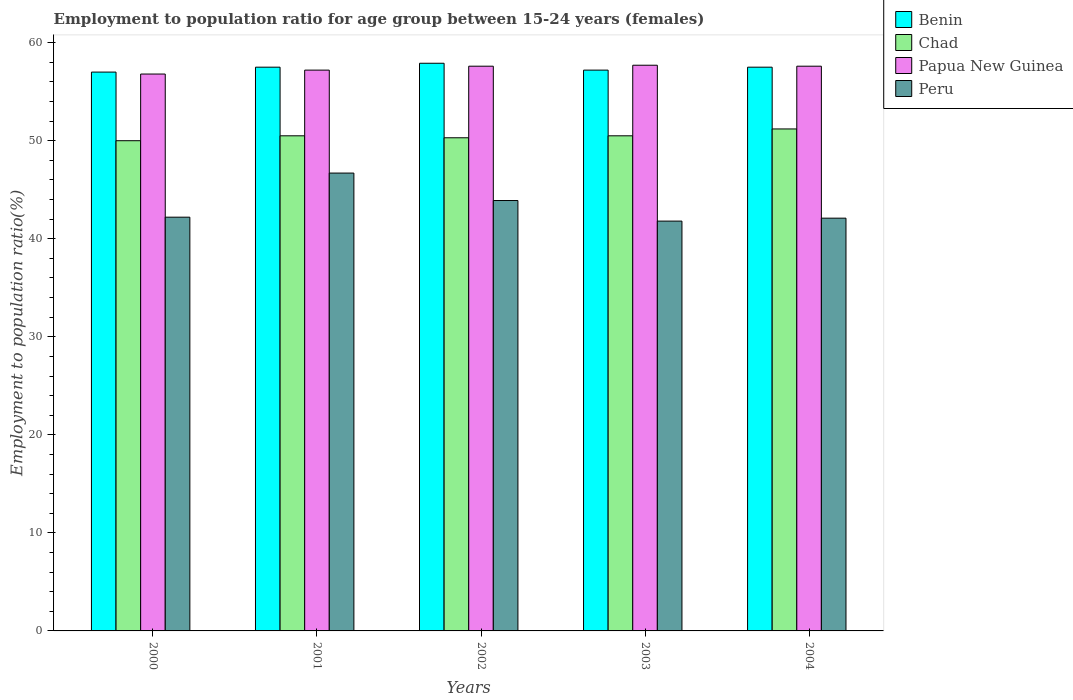How many different coloured bars are there?
Offer a terse response. 4. Are the number of bars per tick equal to the number of legend labels?
Make the answer very short. Yes. Are the number of bars on each tick of the X-axis equal?
Offer a terse response. Yes. How many bars are there on the 2nd tick from the left?
Offer a terse response. 4. What is the employment to population ratio in Peru in 2001?
Your answer should be compact. 46.7. Across all years, what is the maximum employment to population ratio in Papua New Guinea?
Keep it short and to the point. 57.7. Across all years, what is the minimum employment to population ratio in Peru?
Your response must be concise. 41.8. What is the total employment to population ratio in Peru in the graph?
Ensure brevity in your answer.  216.7. What is the difference between the employment to population ratio in Peru in 2000 and that in 2001?
Your answer should be compact. -4.5. What is the difference between the employment to population ratio in Benin in 2003 and the employment to population ratio in Papua New Guinea in 2002?
Ensure brevity in your answer.  -0.4. What is the average employment to population ratio in Peru per year?
Provide a short and direct response. 43.34. In the year 2002, what is the difference between the employment to population ratio in Papua New Guinea and employment to population ratio in Peru?
Offer a terse response. 13.7. In how many years, is the employment to population ratio in Peru greater than 12 %?
Make the answer very short. 5. What is the ratio of the employment to population ratio in Benin in 2002 to that in 2004?
Keep it short and to the point. 1.01. What is the difference between the highest and the second highest employment to population ratio in Peru?
Give a very brief answer. 2.8. What is the difference between the highest and the lowest employment to population ratio in Benin?
Your answer should be very brief. 0.9. In how many years, is the employment to population ratio in Chad greater than the average employment to population ratio in Chad taken over all years?
Your response must be concise. 1. Is the sum of the employment to population ratio in Benin in 2002 and 2003 greater than the maximum employment to population ratio in Peru across all years?
Your answer should be compact. Yes. Is it the case that in every year, the sum of the employment to population ratio in Benin and employment to population ratio in Chad is greater than the sum of employment to population ratio in Papua New Guinea and employment to population ratio in Peru?
Offer a terse response. Yes. What does the 3rd bar from the left in 2004 represents?
Give a very brief answer. Papua New Guinea. What does the 2nd bar from the right in 2002 represents?
Provide a short and direct response. Papua New Guinea. Is it the case that in every year, the sum of the employment to population ratio in Benin and employment to population ratio in Chad is greater than the employment to population ratio in Peru?
Your answer should be very brief. Yes. Are all the bars in the graph horizontal?
Your answer should be very brief. No. Where does the legend appear in the graph?
Your answer should be very brief. Top right. How many legend labels are there?
Offer a very short reply. 4. What is the title of the graph?
Your answer should be very brief. Employment to population ratio for age group between 15-24 years (females). What is the Employment to population ratio(%) of Benin in 2000?
Offer a very short reply. 57. What is the Employment to population ratio(%) of Chad in 2000?
Your answer should be very brief. 50. What is the Employment to population ratio(%) in Papua New Guinea in 2000?
Your answer should be compact. 56.8. What is the Employment to population ratio(%) in Peru in 2000?
Your response must be concise. 42.2. What is the Employment to population ratio(%) of Benin in 2001?
Provide a succinct answer. 57.5. What is the Employment to population ratio(%) in Chad in 2001?
Ensure brevity in your answer.  50.5. What is the Employment to population ratio(%) in Papua New Guinea in 2001?
Offer a very short reply. 57.2. What is the Employment to population ratio(%) of Peru in 2001?
Give a very brief answer. 46.7. What is the Employment to population ratio(%) in Benin in 2002?
Your answer should be very brief. 57.9. What is the Employment to population ratio(%) of Chad in 2002?
Give a very brief answer. 50.3. What is the Employment to population ratio(%) in Papua New Guinea in 2002?
Offer a terse response. 57.6. What is the Employment to population ratio(%) in Peru in 2002?
Provide a short and direct response. 43.9. What is the Employment to population ratio(%) of Benin in 2003?
Offer a terse response. 57.2. What is the Employment to population ratio(%) in Chad in 2003?
Provide a short and direct response. 50.5. What is the Employment to population ratio(%) in Papua New Guinea in 2003?
Your response must be concise. 57.7. What is the Employment to population ratio(%) of Peru in 2003?
Offer a very short reply. 41.8. What is the Employment to population ratio(%) of Benin in 2004?
Your answer should be compact. 57.5. What is the Employment to population ratio(%) in Chad in 2004?
Ensure brevity in your answer.  51.2. What is the Employment to population ratio(%) of Papua New Guinea in 2004?
Offer a terse response. 57.6. What is the Employment to population ratio(%) of Peru in 2004?
Offer a very short reply. 42.1. Across all years, what is the maximum Employment to population ratio(%) of Benin?
Make the answer very short. 57.9. Across all years, what is the maximum Employment to population ratio(%) in Chad?
Give a very brief answer. 51.2. Across all years, what is the maximum Employment to population ratio(%) of Papua New Guinea?
Offer a terse response. 57.7. Across all years, what is the maximum Employment to population ratio(%) of Peru?
Provide a short and direct response. 46.7. Across all years, what is the minimum Employment to population ratio(%) in Papua New Guinea?
Your answer should be very brief. 56.8. Across all years, what is the minimum Employment to population ratio(%) in Peru?
Your answer should be very brief. 41.8. What is the total Employment to population ratio(%) of Benin in the graph?
Make the answer very short. 287.1. What is the total Employment to population ratio(%) in Chad in the graph?
Offer a very short reply. 252.5. What is the total Employment to population ratio(%) of Papua New Guinea in the graph?
Offer a terse response. 286.9. What is the total Employment to population ratio(%) of Peru in the graph?
Make the answer very short. 216.7. What is the difference between the Employment to population ratio(%) in Benin in 2000 and that in 2001?
Offer a very short reply. -0.5. What is the difference between the Employment to population ratio(%) in Benin in 2000 and that in 2002?
Make the answer very short. -0.9. What is the difference between the Employment to population ratio(%) of Chad in 2000 and that in 2002?
Give a very brief answer. -0.3. What is the difference between the Employment to population ratio(%) of Peru in 2000 and that in 2002?
Your answer should be very brief. -1.7. What is the difference between the Employment to population ratio(%) of Benin in 2000 and that in 2004?
Provide a short and direct response. -0.5. What is the difference between the Employment to population ratio(%) of Papua New Guinea in 2000 and that in 2004?
Ensure brevity in your answer.  -0.8. What is the difference between the Employment to population ratio(%) of Peru in 2000 and that in 2004?
Ensure brevity in your answer.  0.1. What is the difference between the Employment to population ratio(%) of Benin in 2001 and that in 2002?
Give a very brief answer. -0.4. What is the difference between the Employment to population ratio(%) in Papua New Guinea in 2001 and that in 2002?
Ensure brevity in your answer.  -0.4. What is the difference between the Employment to population ratio(%) of Peru in 2001 and that in 2002?
Your response must be concise. 2.8. What is the difference between the Employment to population ratio(%) in Benin in 2002 and that in 2003?
Make the answer very short. 0.7. What is the difference between the Employment to population ratio(%) of Chad in 2002 and that in 2003?
Ensure brevity in your answer.  -0.2. What is the difference between the Employment to population ratio(%) of Benin in 2003 and that in 2004?
Your answer should be very brief. -0.3. What is the difference between the Employment to population ratio(%) of Papua New Guinea in 2003 and that in 2004?
Offer a very short reply. 0.1. What is the difference between the Employment to population ratio(%) in Benin in 2000 and the Employment to population ratio(%) in Chad in 2001?
Make the answer very short. 6.5. What is the difference between the Employment to population ratio(%) of Chad in 2000 and the Employment to population ratio(%) of Papua New Guinea in 2001?
Keep it short and to the point. -7.2. What is the difference between the Employment to population ratio(%) in Papua New Guinea in 2000 and the Employment to population ratio(%) in Peru in 2001?
Offer a terse response. 10.1. What is the difference between the Employment to population ratio(%) of Benin in 2000 and the Employment to population ratio(%) of Chad in 2002?
Your answer should be very brief. 6.7. What is the difference between the Employment to population ratio(%) in Benin in 2000 and the Employment to population ratio(%) in Peru in 2003?
Give a very brief answer. 15.2. What is the difference between the Employment to population ratio(%) in Chad in 2000 and the Employment to population ratio(%) in Papua New Guinea in 2003?
Make the answer very short. -7.7. What is the difference between the Employment to population ratio(%) in Chad in 2000 and the Employment to population ratio(%) in Peru in 2003?
Your answer should be compact. 8.2. What is the difference between the Employment to population ratio(%) of Papua New Guinea in 2000 and the Employment to population ratio(%) of Peru in 2003?
Your answer should be very brief. 15. What is the difference between the Employment to population ratio(%) of Benin in 2000 and the Employment to population ratio(%) of Chad in 2004?
Offer a terse response. 5.8. What is the difference between the Employment to population ratio(%) of Chad in 2000 and the Employment to population ratio(%) of Papua New Guinea in 2004?
Your answer should be compact. -7.6. What is the difference between the Employment to population ratio(%) of Papua New Guinea in 2000 and the Employment to population ratio(%) of Peru in 2004?
Ensure brevity in your answer.  14.7. What is the difference between the Employment to population ratio(%) of Benin in 2001 and the Employment to population ratio(%) of Papua New Guinea in 2002?
Give a very brief answer. -0.1. What is the difference between the Employment to population ratio(%) in Benin in 2001 and the Employment to population ratio(%) in Peru in 2002?
Make the answer very short. 13.6. What is the difference between the Employment to population ratio(%) of Benin in 2001 and the Employment to population ratio(%) of Chad in 2003?
Offer a very short reply. 7. What is the difference between the Employment to population ratio(%) of Chad in 2001 and the Employment to population ratio(%) of Peru in 2003?
Your answer should be very brief. 8.7. What is the difference between the Employment to population ratio(%) of Papua New Guinea in 2001 and the Employment to population ratio(%) of Peru in 2003?
Your answer should be compact. 15.4. What is the difference between the Employment to population ratio(%) of Benin in 2001 and the Employment to population ratio(%) of Chad in 2004?
Give a very brief answer. 6.3. What is the difference between the Employment to population ratio(%) of Benin in 2002 and the Employment to population ratio(%) of Chad in 2003?
Ensure brevity in your answer.  7.4. What is the difference between the Employment to population ratio(%) of Chad in 2002 and the Employment to population ratio(%) of Papua New Guinea in 2003?
Your response must be concise. -7.4. What is the difference between the Employment to population ratio(%) of Papua New Guinea in 2002 and the Employment to population ratio(%) of Peru in 2003?
Offer a terse response. 15.8. What is the difference between the Employment to population ratio(%) in Benin in 2002 and the Employment to population ratio(%) in Chad in 2004?
Make the answer very short. 6.7. What is the difference between the Employment to population ratio(%) in Benin in 2002 and the Employment to population ratio(%) in Papua New Guinea in 2004?
Offer a terse response. 0.3. What is the difference between the Employment to population ratio(%) in Benin in 2002 and the Employment to population ratio(%) in Peru in 2004?
Keep it short and to the point. 15.8. What is the difference between the Employment to population ratio(%) in Chad in 2002 and the Employment to population ratio(%) in Papua New Guinea in 2004?
Your answer should be compact. -7.3. What is the difference between the Employment to population ratio(%) of Chad in 2002 and the Employment to population ratio(%) of Peru in 2004?
Keep it short and to the point. 8.2. What is the difference between the Employment to population ratio(%) in Benin in 2003 and the Employment to population ratio(%) in Chad in 2004?
Your answer should be compact. 6. What is the difference between the Employment to population ratio(%) of Benin in 2003 and the Employment to population ratio(%) of Papua New Guinea in 2004?
Offer a terse response. -0.4. What is the difference between the Employment to population ratio(%) in Benin in 2003 and the Employment to population ratio(%) in Peru in 2004?
Offer a very short reply. 15.1. What is the difference between the Employment to population ratio(%) in Chad in 2003 and the Employment to population ratio(%) in Papua New Guinea in 2004?
Give a very brief answer. -7.1. What is the difference between the Employment to population ratio(%) of Papua New Guinea in 2003 and the Employment to population ratio(%) of Peru in 2004?
Provide a succinct answer. 15.6. What is the average Employment to population ratio(%) of Benin per year?
Give a very brief answer. 57.42. What is the average Employment to population ratio(%) of Chad per year?
Your answer should be compact. 50.5. What is the average Employment to population ratio(%) of Papua New Guinea per year?
Offer a very short reply. 57.38. What is the average Employment to population ratio(%) of Peru per year?
Your answer should be very brief. 43.34. In the year 2000, what is the difference between the Employment to population ratio(%) of Benin and Employment to population ratio(%) of Chad?
Your answer should be compact. 7. In the year 2000, what is the difference between the Employment to population ratio(%) of Benin and Employment to population ratio(%) of Papua New Guinea?
Offer a very short reply. 0.2. In the year 2000, what is the difference between the Employment to population ratio(%) in Benin and Employment to population ratio(%) in Peru?
Your answer should be compact. 14.8. In the year 2000, what is the difference between the Employment to population ratio(%) of Chad and Employment to population ratio(%) of Peru?
Provide a short and direct response. 7.8. In the year 2001, what is the difference between the Employment to population ratio(%) in Benin and Employment to population ratio(%) in Peru?
Provide a succinct answer. 10.8. In the year 2001, what is the difference between the Employment to population ratio(%) in Chad and Employment to population ratio(%) in Papua New Guinea?
Provide a succinct answer. -6.7. In the year 2001, what is the difference between the Employment to population ratio(%) in Papua New Guinea and Employment to population ratio(%) in Peru?
Your answer should be very brief. 10.5. In the year 2002, what is the difference between the Employment to population ratio(%) of Benin and Employment to population ratio(%) of Peru?
Provide a succinct answer. 14. In the year 2003, what is the difference between the Employment to population ratio(%) in Benin and Employment to population ratio(%) in Papua New Guinea?
Keep it short and to the point. -0.5. In the year 2003, what is the difference between the Employment to population ratio(%) in Chad and Employment to population ratio(%) in Papua New Guinea?
Give a very brief answer. -7.2. In the year 2003, what is the difference between the Employment to population ratio(%) in Chad and Employment to population ratio(%) in Peru?
Keep it short and to the point. 8.7. In the year 2004, what is the difference between the Employment to population ratio(%) in Benin and Employment to population ratio(%) in Chad?
Offer a very short reply. 6.3. In the year 2004, what is the difference between the Employment to population ratio(%) in Benin and Employment to population ratio(%) in Papua New Guinea?
Provide a short and direct response. -0.1. In the year 2004, what is the difference between the Employment to population ratio(%) in Chad and Employment to population ratio(%) in Papua New Guinea?
Your answer should be very brief. -6.4. What is the ratio of the Employment to population ratio(%) of Benin in 2000 to that in 2001?
Provide a succinct answer. 0.99. What is the ratio of the Employment to population ratio(%) of Chad in 2000 to that in 2001?
Offer a terse response. 0.99. What is the ratio of the Employment to population ratio(%) in Peru in 2000 to that in 2001?
Provide a succinct answer. 0.9. What is the ratio of the Employment to population ratio(%) of Benin in 2000 to that in 2002?
Offer a terse response. 0.98. What is the ratio of the Employment to population ratio(%) of Chad in 2000 to that in 2002?
Provide a succinct answer. 0.99. What is the ratio of the Employment to population ratio(%) of Papua New Guinea in 2000 to that in 2002?
Offer a terse response. 0.99. What is the ratio of the Employment to population ratio(%) of Peru in 2000 to that in 2002?
Provide a short and direct response. 0.96. What is the ratio of the Employment to population ratio(%) of Chad in 2000 to that in 2003?
Provide a short and direct response. 0.99. What is the ratio of the Employment to population ratio(%) in Papua New Guinea in 2000 to that in 2003?
Ensure brevity in your answer.  0.98. What is the ratio of the Employment to population ratio(%) in Peru in 2000 to that in 2003?
Ensure brevity in your answer.  1.01. What is the ratio of the Employment to population ratio(%) in Chad in 2000 to that in 2004?
Make the answer very short. 0.98. What is the ratio of the Employment to population ratio(%) of Papua New Guinea in 2000 to that in 2004?
Keep it short and to the point. 0.99. What is the ratio of the Employment to population ratio(%) in Peru in 2001 to that in 2002?
Provide a succinct answer. 1.06. What is the ratio of the Employment to population ratio(%) of Benin in 2001 to that in 2003?
Provide a short and direct response. 1.01. What is the ratio of the Employment to population ratio(%) in Papua New Guinea in 2001 to that in 2003?
Offer a terse response. 0.99. What is the ratio of the Employment to population ratio(%) in Peru in 2001 to that in 2003?
Provide a short and direct response. 1.12. What is the ratio of the Employment to population ratio(%) of Chad in 2001 to that in 2004?
Your response must be concise. 0.99. What is the ratio of the Employment to population ratio(%) of Papua New Guinea in 2001 to that in 2004?
Keep it short and to the point. 0.99. What is the ratio of the Employment to population ratio(%) in Peru in 2001 to that in 2004?
Offer a very short reply. 1.11. What is the ratio of the Employment to population ratio(%) of Benin in 2002 to that in 2003?
Offer a terse response. 1.01. What is the ratio of the Employment to population ratio(%) of Peru in 2002 to that in 2003?
Provide a short and direct response. 1.05. What is the ratio of the Employment to population ratio(%) in Benin in 2002 to that in 2004?
Give a very brief answer. 1.01. What is the ratio of the Employment to population ratio(%) of Chad in 2002 to that in 2004?
Offer a terse response. 0.98. What is the ratio of the Employment to population ratio(%) of Peru in 2002 to that in 2004?
Your response must be concise. 1.04. What is the ratio of the Employment to population ratio(%) of Benin in 2003 to that in 2004?
Give a very brief answer. 0.99. What is the ratio of the Employment to population ratio(%) of Chad in 2003 to that in 2004?
Ensure brevity in your answer.  0.99. What is the ratio of the Employment to population ratio(%) in Papua New Guinea in 2003 to that in 2004?
Your answer should be very brief. 1. What is the ratio of the Employment to population ratio(%) in Peru in 2003 to that in 2004?
Provide a succinct answer. 0.99. What is the difference between the highest and the second highest Employment to population ratio(%) of Benin?
Ensure brevity in your answer.  0.4. What is the difference between the highest and the second highest Employment to population ratio(%) in Chad?
Your answer should be very brief. 0.7. What is the difference between the highest and the second highest Employment to population ratio(%) of Papua New Guinea?
Provide a succinct answer. 0.1. 